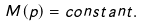<formula> <loc_0><loc_0><loc_500><loc_500>M ( p ) = c o n s t a n t .</formula> 